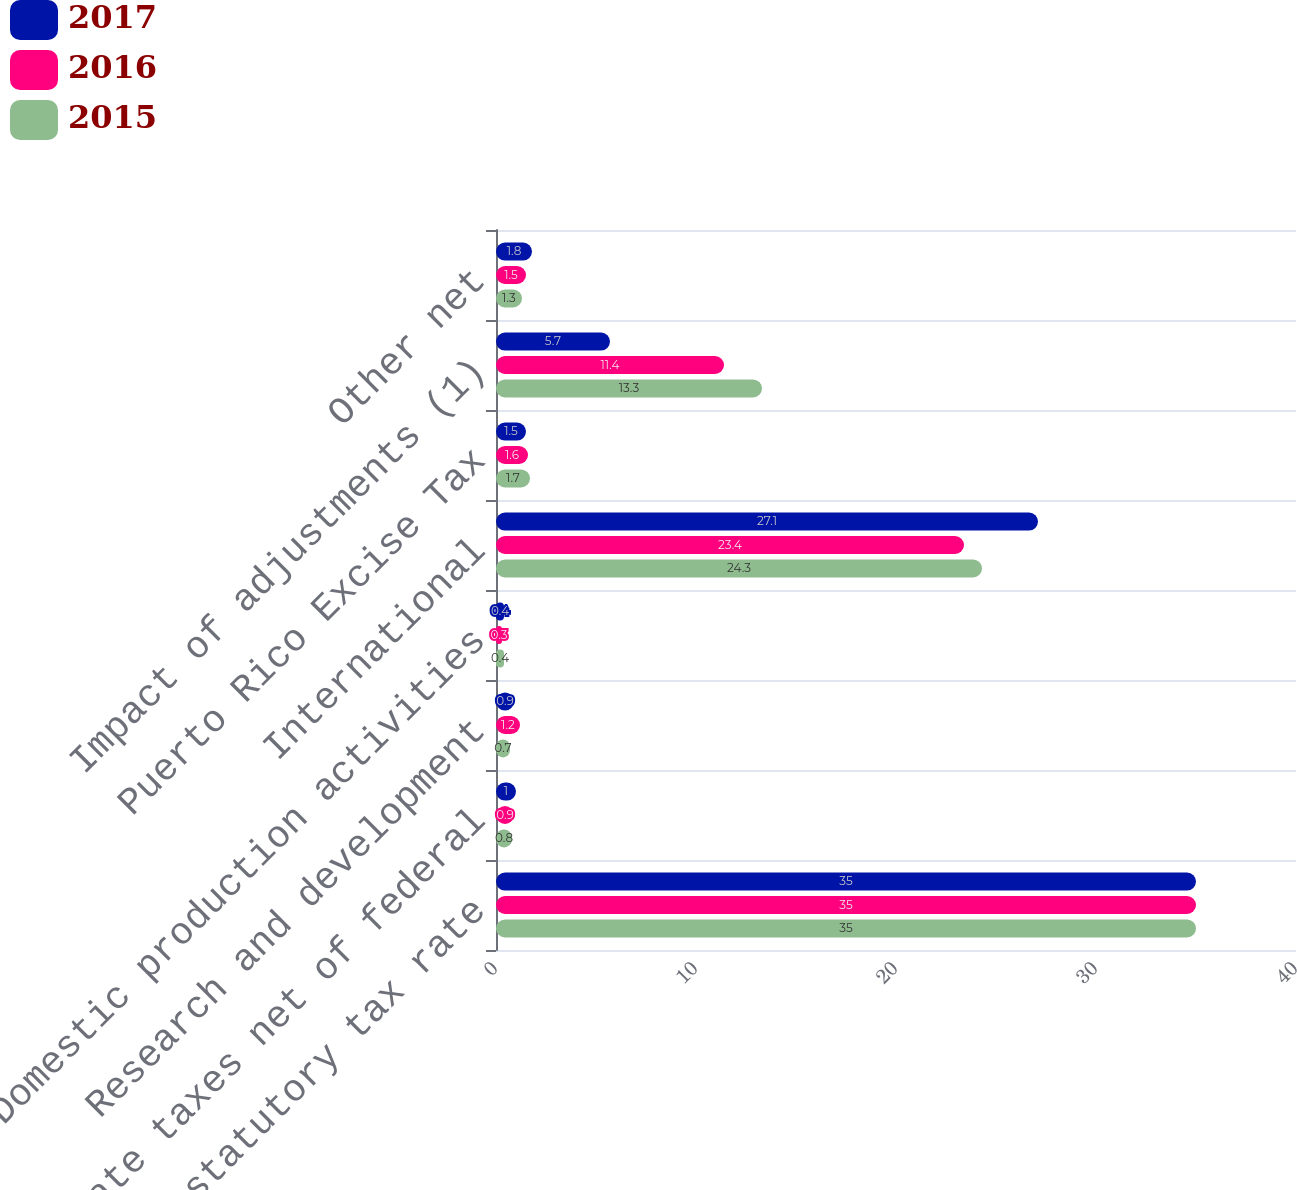Convert chart to OTSL. <chart><loc_0><loc_0><loc_500><loc_500><stacked_bar_chart><ecel><fcel>US federal statutory tax rate<fcel>US state taxes net of federal<fcel>Research and development<fcel>Domestic production activities<fcel>International<fcel>Puerto Rico Excise Tax<fcel>Impact of adjustments (1)<fcel>Other net<nl><fcel>2017<fcel>35<fcel>1<fcel>0.9<fcel>0.4<fcel>27.1<fcel>1.5<fcel>5.7<fcel>1.8<nl><fcel>2016<fcel>35<fcel>0.9<fcel>1.2<fcel>0.3<fcel>23.4<fcel>1.6<fcel>11.4<fcel>1.5<nl><fcel>2015<fcel>35<fcel>0.8<fcel>0.7<fcel>0.4<fcel>24.3<fcel>1.7<fcel>13.3<fcel>1.3<nl></chart> 